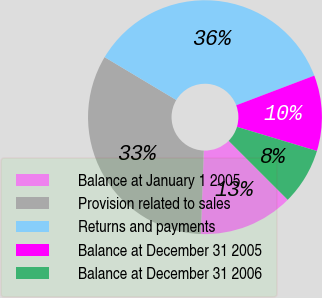Convert chart to OTSL. <chart><loc_0><loc_0><loc_500><loc_500><pie_chart><fcel>Balance at January 1 2005<fcel>Provision related to sales<fcel>Returns and payments<fcel>Balance at December 31 2005<fcel>Balance at December 31 2006<nl><fcel>13.08%<fcel>33.01%<fcel>35.64%<fcel>10.45%<fcel>7.82%<nl></chart> 